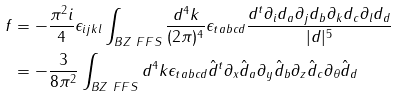<formula> <loc_0><loc_0><loc_500><loc_500>f & = - \frac { \pi ^ { 2 } i } { 4 } \epsilon _ { i j k l } \int _ { B Z \ F F S } \frac { d ^ { 4 } k } { ( 2 \pi ) ^ { 4 } } \epsilon _ { t a b c d } \frac { d ^ { t } \partial _ { i } d _ { a } \partial _ { j } d _ { b } \partial _ { k } d _ { c } \partial _ { l } d _ { d } } { | d | ^ { 5 } } \\ & = - \frac { 3 } { 8 \pi ^ { 2 } } \int _ { B Z \ F F S } d ^ { 4 } k \epsilon _ { t a b c d } \hat { d } ^ { t } \partial _ { x } \hat { d } _ { a } \partial _ { y } \hat { d } _ { b } \partial _ { z } \hat { d } _ { c } \partial _ { \theta } \hat { d } _ { d }</formula> 